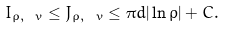<formula> <loc_0><loc_0><loc_500><loc_500>I _ { \rho , \ v } \leq J _ { \rho , \ v } \leq \pi d | \ln \rho | + C .</formula> 